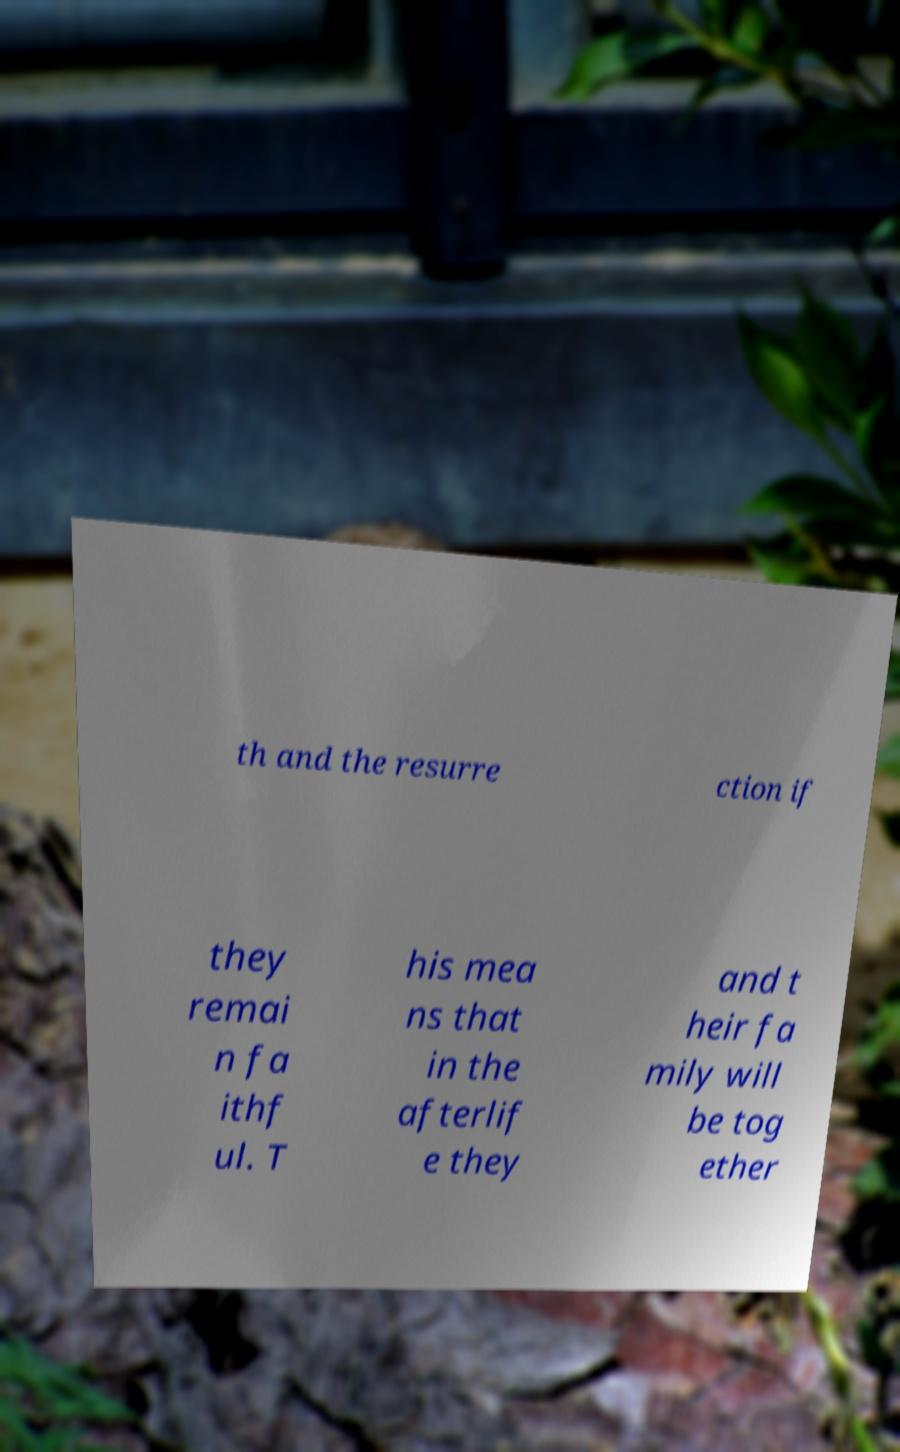There's text embedded in this image that I need extracted. Can you transcribe it verbatim? th and the resurre ction if they remai n fa ithf ul. T his mea ns that in the afterlif e they and t heir fa mily will be tog ether 